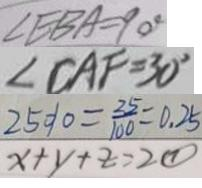<formula> <loc_0><loc_0><loc_500><loc_500>\angle E B A = 9 0 ^ { \circ } 
 \angle C A F = 3 0 ^ { \circ } 
 2 5 \% = \frac { 2 5 } { 1 0 0 } = 0 . 2 5 
 x + y + z = 2 \textcircled { 1 }</formula> 